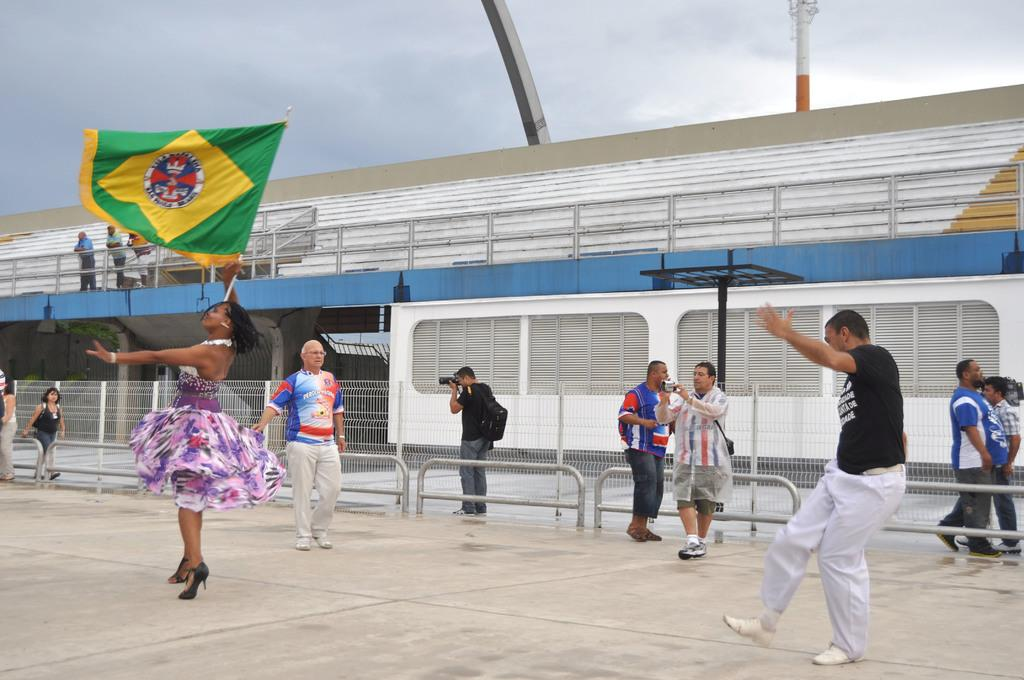How many persons can be seen in the image? There are persons in the image, but the exact number is not specified. What is one person doing in the image? One person is holding a flag. What can be seen in the background of the image? There is a fence, poles, and a bridge in the background of the image. What is visible in the sky in the image? The sky is visible in the image. What type of alarm is going off in the image? There is no alarm present in the image. How many weeks have passed since the event depicted in the image? The image does not provide any information about the passage of time or any specific event, so it is impossible to determine how many weeks have passed. 